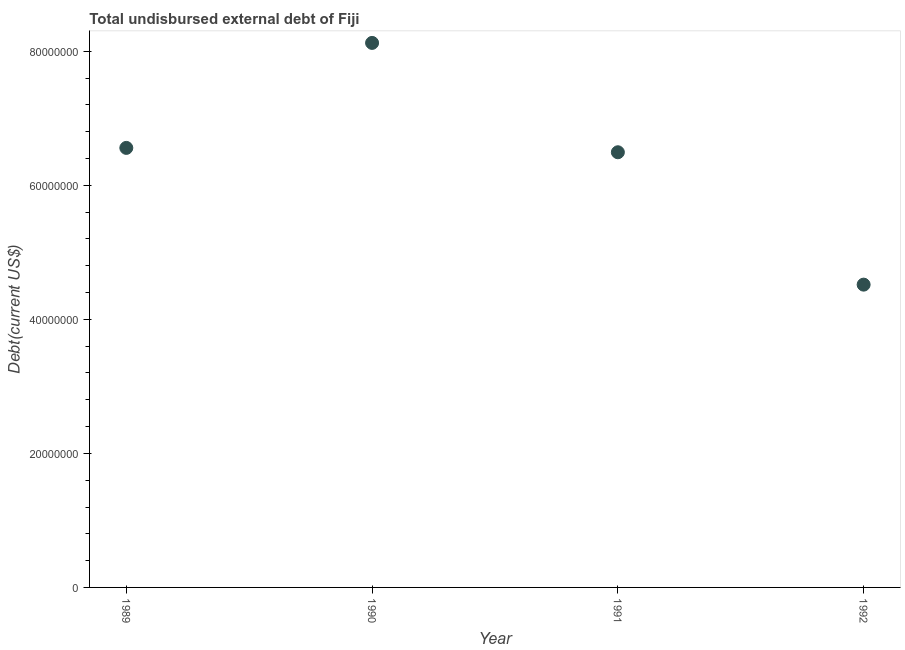What is the total debt in 1992?
Provide a short and direct response. 4.52e+07. Across all years, what is the maximum total debt?
Your answer should be very brief. 8.12e+07. Across all years, what is the minimum total debt?
Offer a terse response. 4.52e+07. In which year was the total debt maximum?
Your answer should be compact. 1990. In which year was the total debt minimum?
Ensure brevity in your answer.  1992. What is the sum of the total debt?
Provide a succinct answer. 2.57e+08. What is the difference between the total debt in 1989 and 1992?
Make the answer very short. 2.04e+07. What is the average total debt per year?
Offer a terse response. 6.42e+07. What is the median total debt?
Give a very brief answer. 6.53e+07. What is the ratio of the total debt in 1989 to that in 1991?
Give a very brief answer. 1.01. Is the total debt in 1989 less than that in 1992?
Provide a short and direct response. No. What is the difference between the highest and the second highest total debt?
Provide a short and direct response. 1.57e+07. What is the difference between the highest and the lowest total debt?
Your answer should be compact. 3.61e+07. How many years are there in the graph?
Make the answer very short. 4. What is the difference between two consecutive major ticks on the Y-axis?
Ensure brevity in your answer.  2.00e+07. Are the values on the major ticks of Y-axis written in scientific E-notation?
Offer a very short reply. No. Does the graph contain any zero values?
Give a very brief answer. No. Does the graph contain grids?
Give a very brief answer. No. What is the title of the graph?
Your answer should be very brief. Total undisbursed external debt of Fiji. What is the label or title of the Y-axis?
Ensure brevity in your answer.  Debt(current US$). What is the Debt(current US$) in 1989?
Your response must be concise. 6.56e+07. What is the Debt(current US$) in 1990?
Offer a terse response. 8.12e+07. What is the Debt(current US$) in 1991?
Offer a terse response. 6.49e+07. What is the Debt(current US$) in 1992?
Your answer should be very brief. 4.52e+07. What is the difference between the Debt(current US$) in 1989 and 1990?
Give a very brief answer. -1.57e+07. What is the difference between the Debt(current US$) in 1989 and 1991?
Offer a very short reply. 6.50e+05. What is the difference between the Debt(current US$) in 1989 and 1992?
Keep it short and to the point. 2.04e+07. What is the difference between the Debt(current US$) in 1990 and 1991?
Provide a short and direct response. 1.63e+07. What is the difference between the Debt(current US$) in 1990 and 1992?
Your answer should be very brief. 3.61e+07. What is the difference between the Debt(current US$) in 1991 and 1992?
Your answer should be compact. 1.98e+07. What is the ratio of the Debt(current US$) in 1989 to that in 1990?
Your answer should be very brief. 0.81. What is the ratio of the Debt(current US$) in 1989 to that in 1991?
Your response must be concise. 1.01. What is the ratio of the Debt(current US$) in 1989 to that in 1992?
Give a very brief answer. 1.45. What is the ratio of the Debt(current US$) in 1990 to that in 1991?
Your response must be concise. 1.25. What is the ratio of the Debt(current US$) in 1990 to that in 1992?
Offer a very short reply. 1.8. What is the ratio of the Debt(current US$) in 1991 to that in 1992?
Provide a short and direct response. 1.44. 